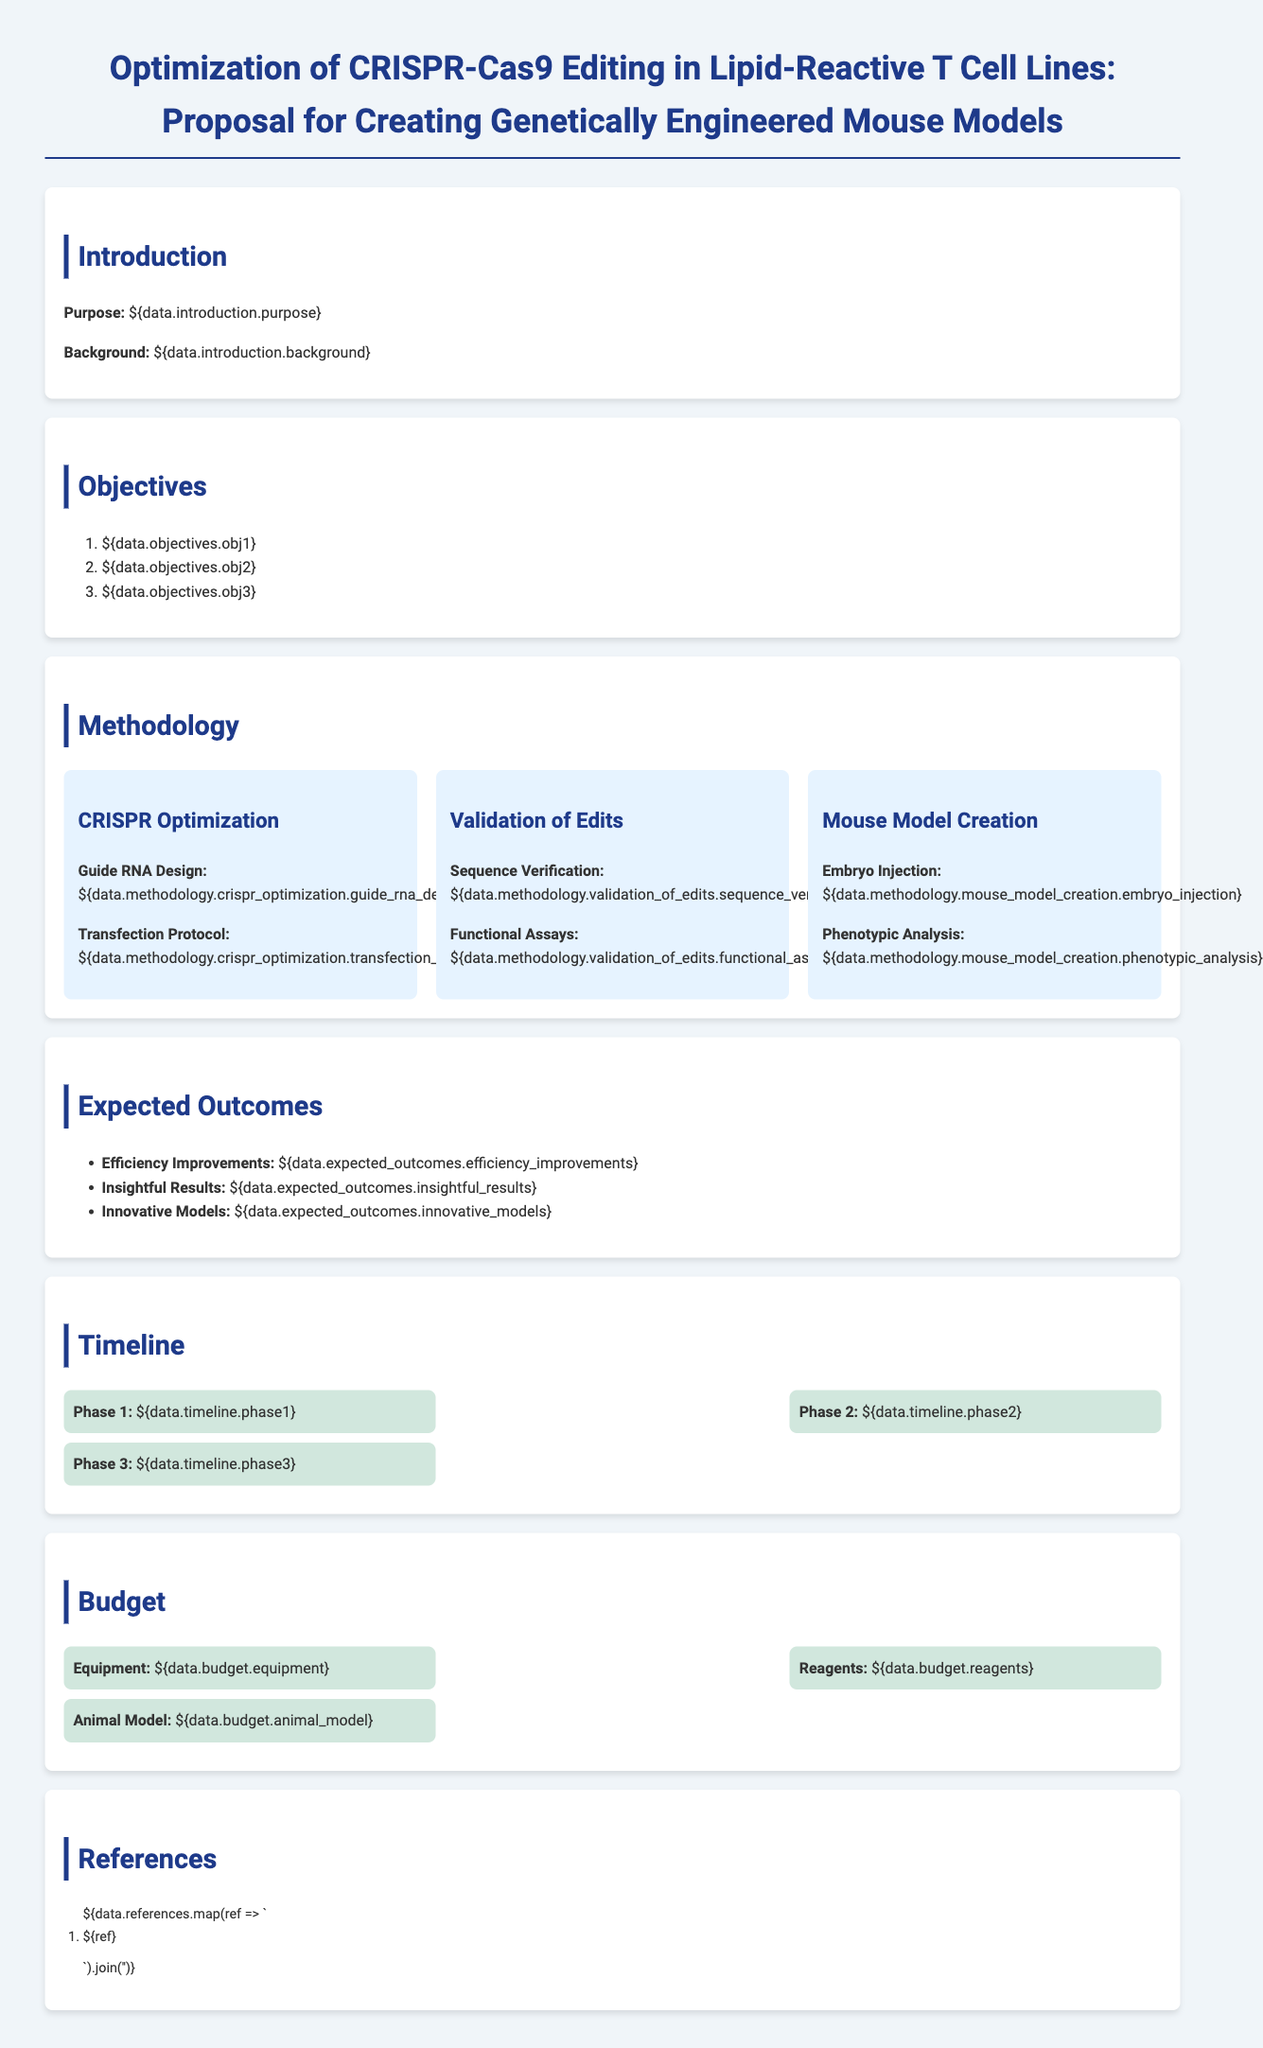What is the purpose of the proposal? The purpose is mentioned in the introduction section of the document, which outlines the main aim of the proposal.
Answer: Optimization of CRISPR-Cas9 Editing in Lipid-Reactive T Cell Lines What are the objectives? The objectives are listed under the objectives section of the document.
Answer: Three objectives What is the first phase of the timeline? The timeline section outlines the phases of the project.
Answer: Phase 1: CRISPR optimization What is the expected outcome regarding innovative models? The expected outcomes section lists the anticipated results from the research.
Answer: Innovative Models What is one method under the validation of edits? The methodology section details specific methods employed for validating the edits made.
Answer: Functional Assays How many sections are there in the document? By counting the sections presented in the document, we can identify the total number.
Answer: Six sections What equipment is listed under the budget? The budget section specifies the items needed for the research proposal.
Answer: Equipment What is the purpose of the CRISPR optimization? Understanding the methodology helps explain the rationale behind optimizing CRISPR-cas9 editing.
Answer: To enhance efficiency and effectiveness What is the funding source mentioned in the proposal? This type of document typically includes a funding section, where sources are disclosed.
Answer: Not specified in the provided information 